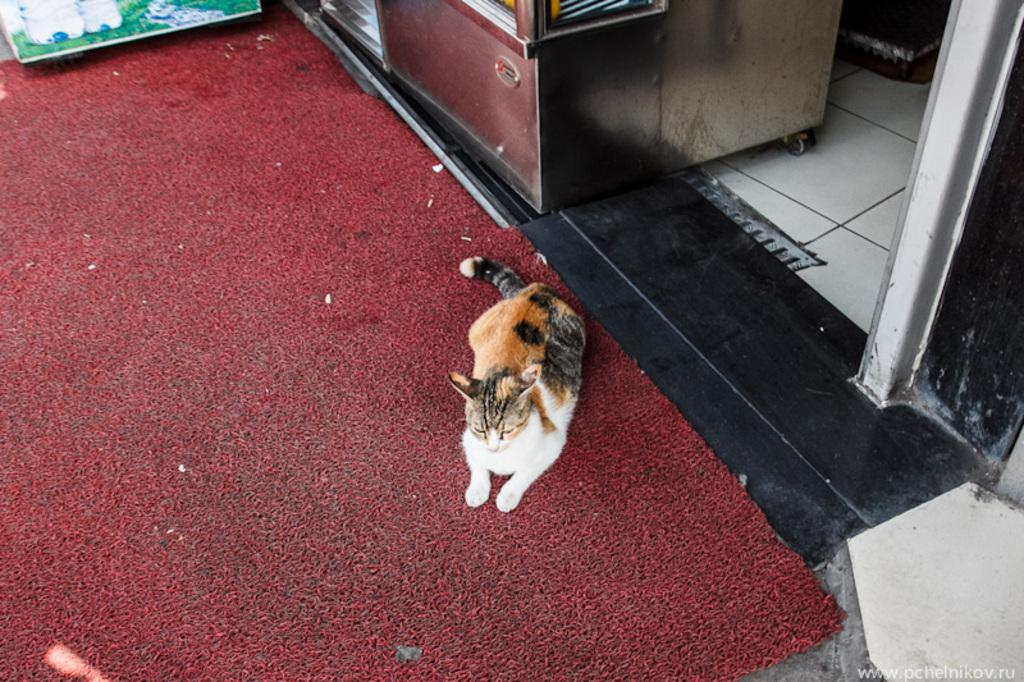What type of animal is sitting on an object in the image? There is a cat sitting on a mat in the image. What is the object that the cat is sitting on? There is a mat in the image. Can you describe the color of the maroon-colored object on the floor? There is a maroon-colored object on the floor in the image. What type of gold object can be seen in the image? There is no gold object present in the image. What type of boundary is visible in the image? There is no boundary visible in the image. What type of lead object can be seen in the image? There is no lead object present in the image. 